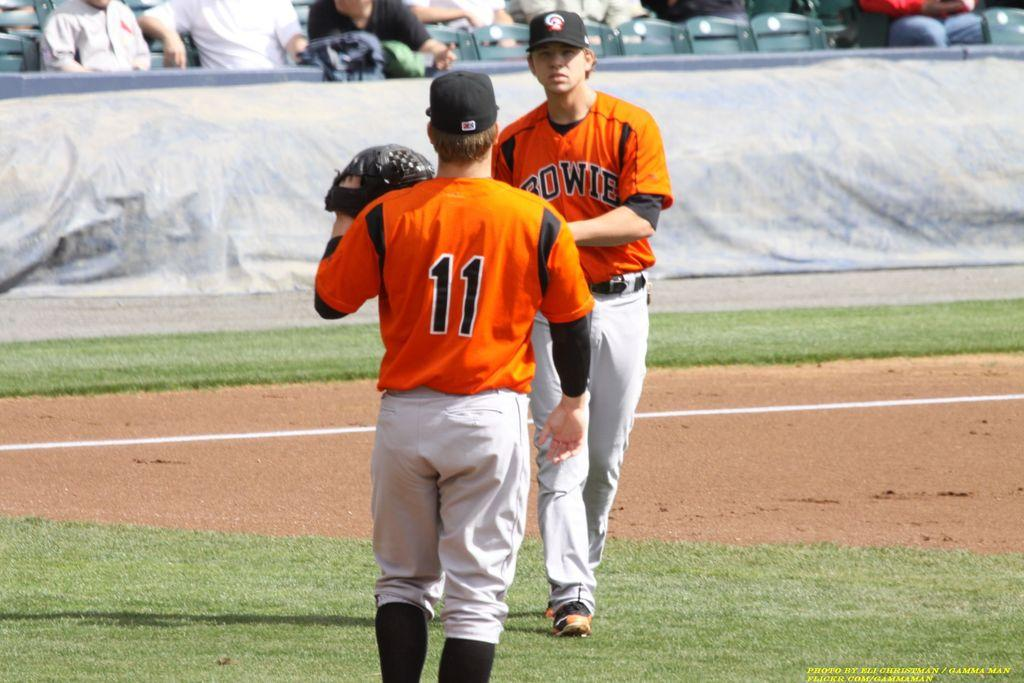Provide a one-sentence caption for the provided image. Bowie is being represented by one of the baseball players. 